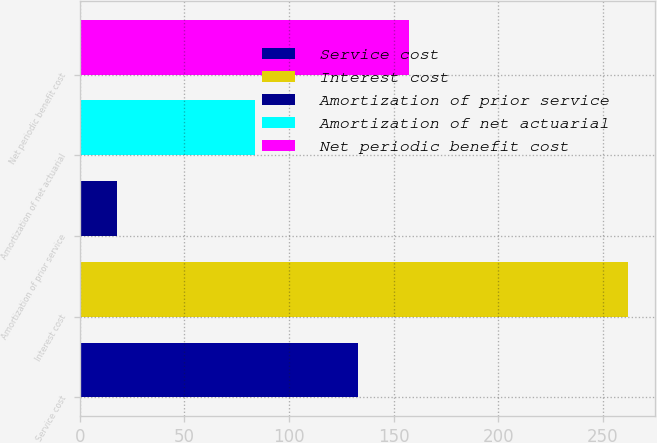Convert chart. <chart><loc_0><loc_0><loc_500><loc_500><bar_chart><fcel>Service cost<fcel>Interest cost<fcel>Amortization of prior service<fcel>Amortization of net actuarial<fcel>Net periodic benefit cost<nl><fcel>133<fcel>262<fcel>18<fcel>84<fcel>157.4<nl></chart> 